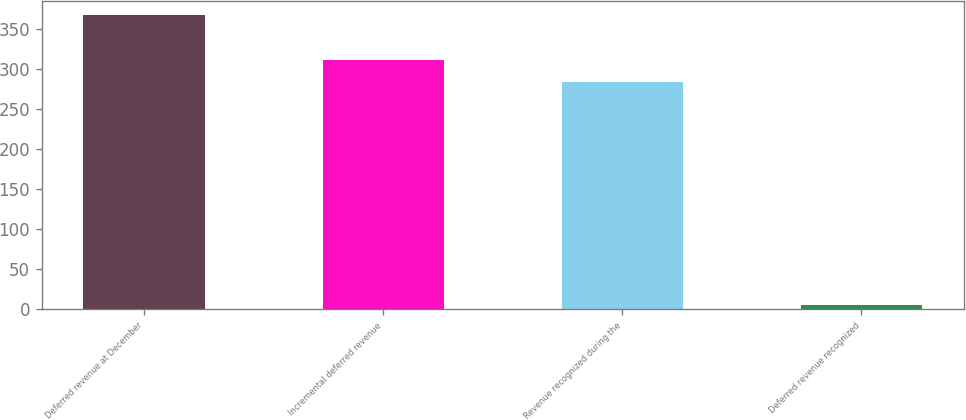Convert chart to OTSL. <chart><loc_0><loc_0><loc_500><loc_500><bar_chart><fcel>Deferred revenue at December<fcel>Incremental deferred revenue<fcel>Revenue recognized during the<fcel>Deferred revenue recognized<nl><fcel>367.4<fcel>311.56<fcel>283.64<fcel>5.5<nl></chart> 